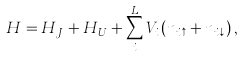<formula> <loc_0><loc_0><loc_500><loc_500>H = H _ { J } + H _ { U } + \sum _ { i } ^ { L } V _ { i } \left ( n _ { i \uparrow } + n _ { i \downarrow } \right ) ,</formula> 